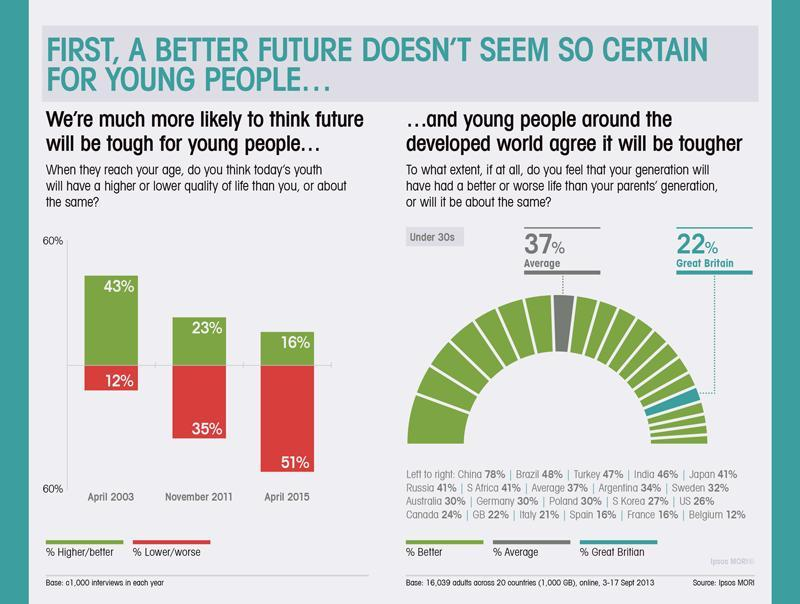Which is the fifth country that believes future living conditions will be better than the older generation?
Answer the question with a short phrase. Japan What color code is higher/better- red, green, blue, yellow? green What color code is Lower/worse- blue, green, red, yellow? red Which is the seventh country that believes living conditions will be better than the older generation? S Africa How many countries believe with less than 20% probability for better living conditions in the future? 3 